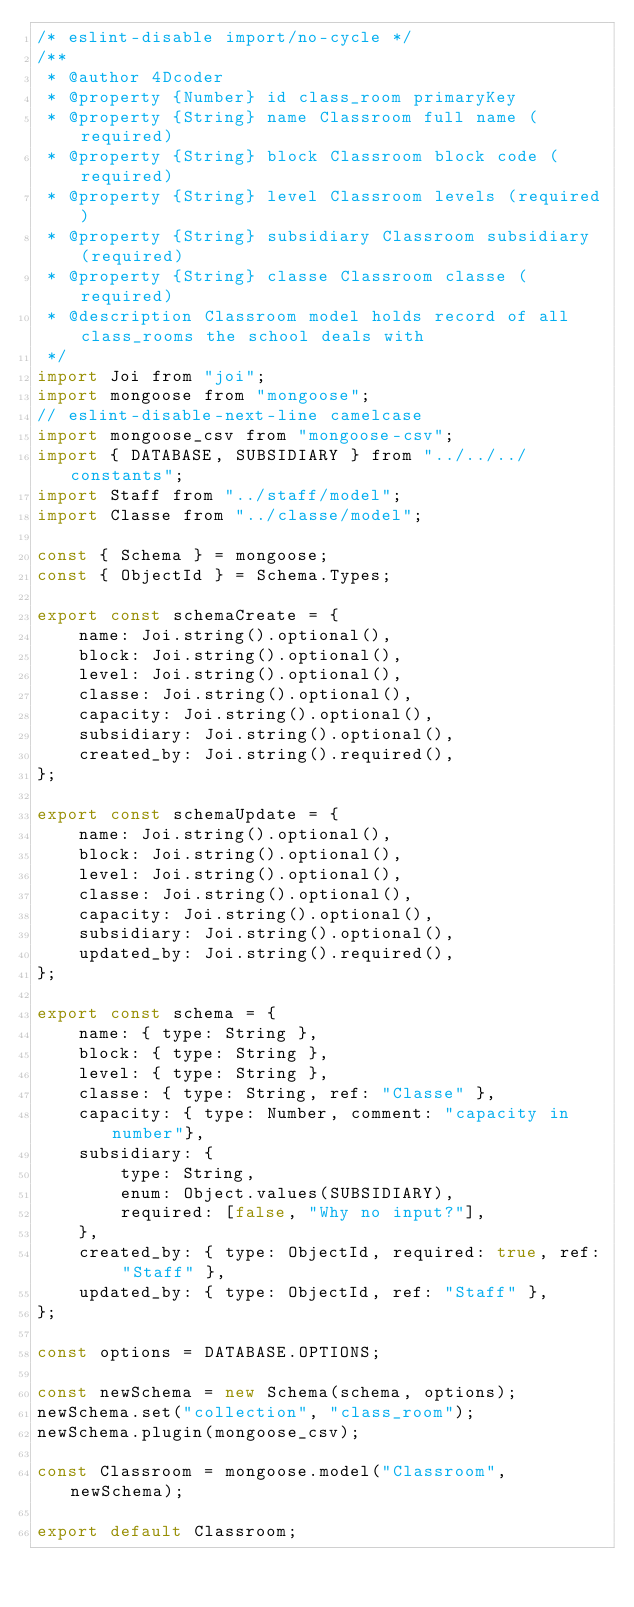<code> <loc_0><loc_0><loc_500><loc_500><_JavaScript_>/* eslint-disable import/no-cycle */
/**
 * @author 4Dcoder
 * @property {Number} id class_room primaryKey
 * @property {String} name Classroom full name (required)
 * @property {String} block Classroom block code (required)
 * @property {String} level Classroom levels (required)
 * @property {String} subsidiary Classroom subsidiary (required)
 * @property {String} classe Classroom classe (required)
 * @description Classroom model holds record of all class_rooms the school deals with
 */
import Joi from "joi";
import mongoose from "mongoose";
// eslint-disable-next-line camelcase
import mongoose_csv from "mongoose-csv";
import { DATABASE, SUBSIDIARY } from "../../../constants";
import Staff from "../staff/model";
import Classe from "../classe/model";

const { Schema } = mongoose;
const { ObjectId } = Schema.Types;

export const schemaCreate = {
    name: Joi.string().optional(),
    block: Joi.string().optional(),
    level: Joi.string().optional(),
    classe: Joi.string().optional(),
    capacity: Joi.string().optional(),
    subsidiary: Joi.string().optional(),
    created_by: Joi.string().required(),
};

export const schemaUpdate = {
    name: Joi.string().optional(),
    block: Joi.string().optional(),
    level: Joi.string().optional(),
    classe: Joi.string().optional(),
    capacity: Joi.string().optional(),
    subsidiary: Joi.string().optional(),
    updated_by: Joi.string().required(),
};

export const schema = {
    name: { type: String },
    block: { type: String },
    level: { type: String },
    classe: { type: String, ref: "Classe" },
    capacity: { type: Number, comment: "capacity in number"},
    subsidiary: {
        type: String,
        enum: Object.values(SUBSIDIARY),
        required: [false, "Why no input?"],
    },
    created_by: { type: ObjectId, required: true, ref: "Staff" },
    updated_by: { type: ObjectId, ref: "Staff" },
};

const options = DATABASE.OPTIONS;

const newSchema = new Schema(schema, options);
newSchema.set("collection", "class_room");
newSchema.plugin(mongoose_csv);

const Classroom = mongoose.model("Classroom", newSchema);

export default Classroom;
</code> 